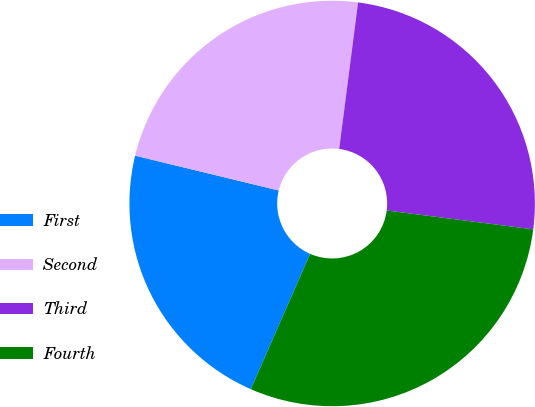<chart> <loc_0><loc_0><loc_500><loc_500><pie_chart><fcel>First<fcel>Second<fcel>Third<fcel>Fourth<nl><fcel>22.22%<fcel>23.25%<fcel>25.0%<fcel>29.54%<nl></chart> 